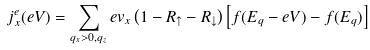Convert formula to latex. <formula><loc_0><loc_0><loc_500><loc_500>j ^ { e } _ { x } ( e V ) = \sum _ { q _ { x } > 0 , q _ { z } } e v _ { x } \left ( 1 - R _ { \uparrow } - R _ { \downarrow } \right ) \left [ f ( E _ { q } - e V ) - f ( E _ { q } ) \right ]</formula> 